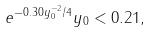Convert formula to latex. <formula><loc_0><loc_0><loc_500><loc_500>e ^ { - 0 . 3 0 y _ { 0 } ^ { - 2 } / 4 } y _ { 0 } < 0 . 2 1 ,</formula> 